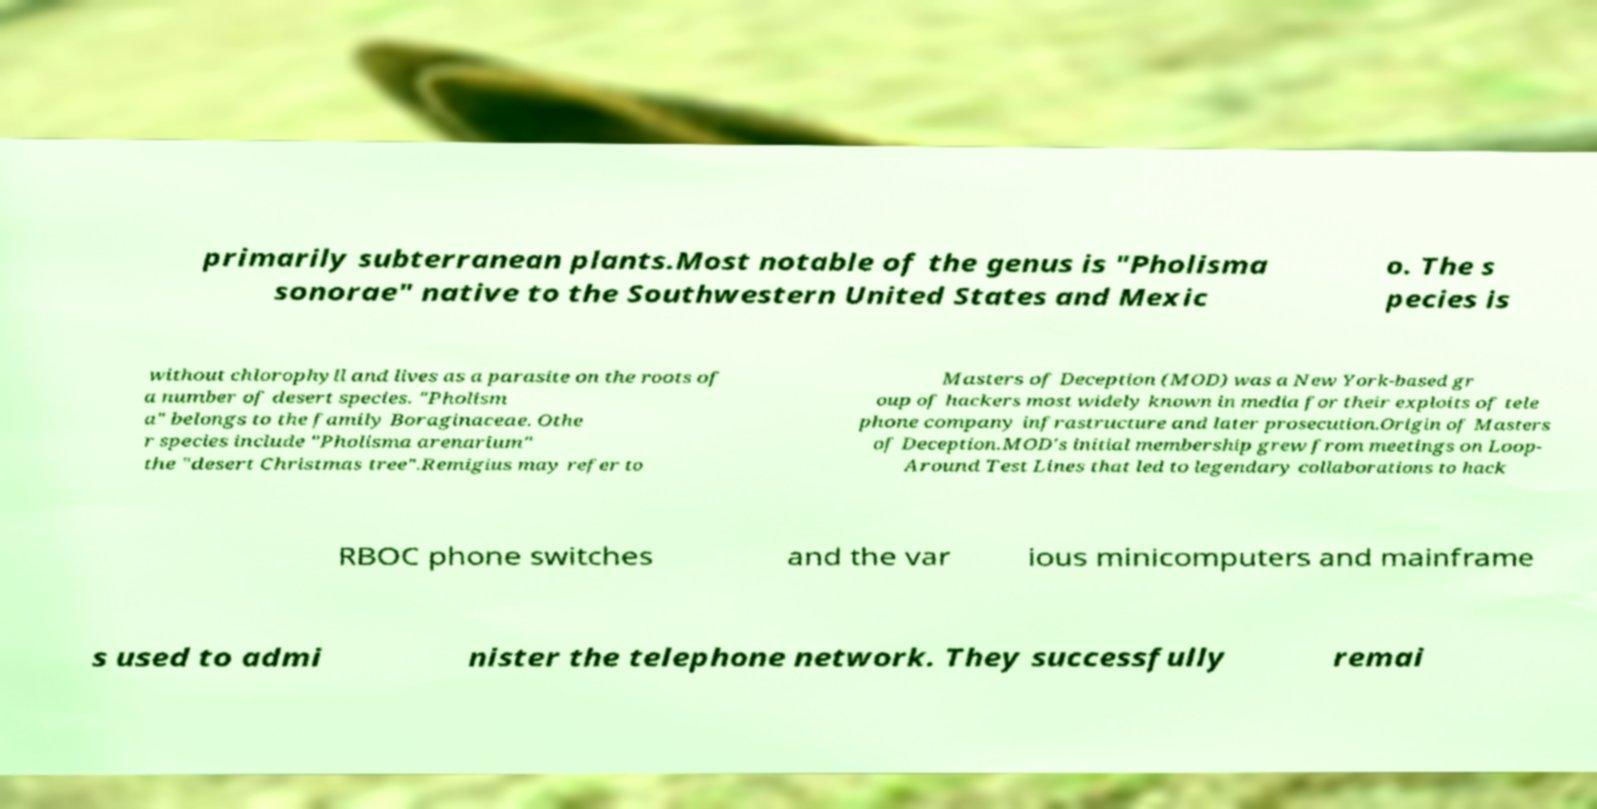There's text embedded in this image that I need extracted. Can you transcribe it verbatim? primarily subterranean plants.Most notable of the genus is "Pholisma sonorae" native to the Southwestern United States and Mexic o. The s pecies is without chlorophyll and lives as a parasite on the roots of a number of desert species. "Pholism a" belongs to the family Boraginaceae. Othe r species include "Pholisma arenarium" the "desert Christmas tree".Remigius may refer to Masters of Deception (MOD) was a New York-based gr oup of hackers most widely known in media for their exploits of tele phone company infrastructure and later prosecution.Origin of Masters of Deception.MOD's initial membership grew from meetings on Loop- Around Test Lines that led to legendary collaborations to hack RBOC phone switches and the var ious minicomputers and mainframe s used to admi nister the telephone network. They successfully remai 